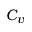<formula> <loc_0><loc_0><loc_500><loc_500>C _ { v }</formula> 